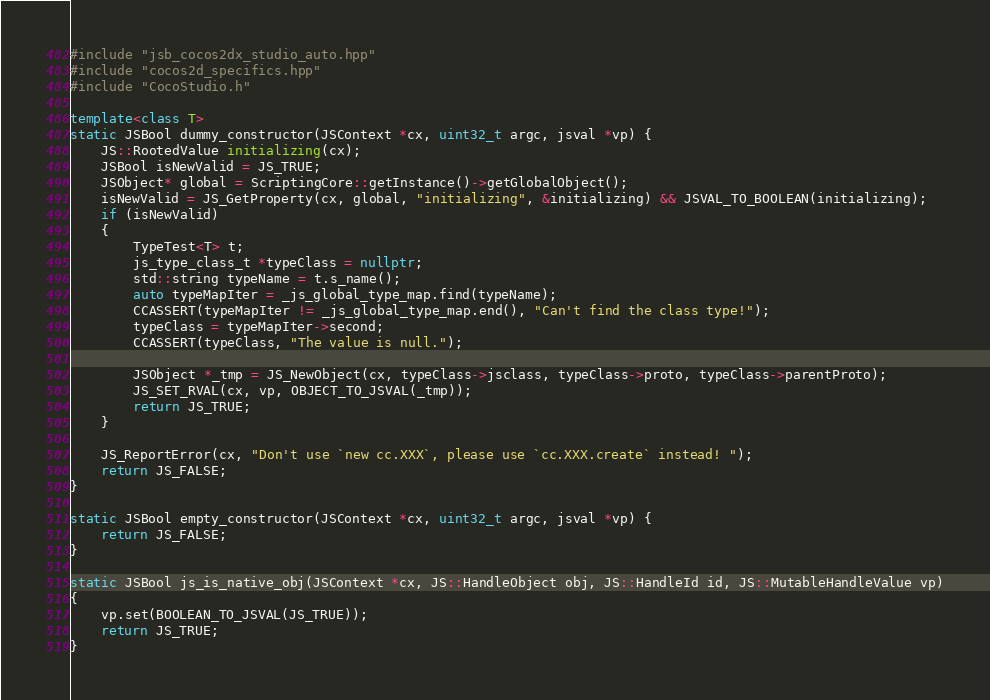<code> <loc_0><loc_0><loc_500><loc_500><_C++_>#include "jsb_cocos2dx_studio_auto.hpp"
#include "cocos2d_specifics.hpp"
#include "CocoStudio.h"

template<class T>
static JSBool dummy_constructor(JSContext *cx, uint32_t argc, jsval *vp) {
    JS::RootedValue initializing(cx);
    JSBool isNewValid = JS_TRUE;
    JSObject* global = ScriptingCore::getInstance()->getGlobalObject();
	isNewValid = JS_GetProperty(cx, global, "initializing", &initializing) && JSVAL_TO_BOOLEAN(initializing);
	if (isNewValid)
	{
		TypeTest<T> t;
		js_type_class_t *typeClass = nullptr;
		std::string typeName = t.s_name();
		auto typeMapIter = _js_global_type_map.find(typeName);
		CCASSERT(typeMapIter != _js_global_type_map.end(), "Can't find the class type!");
		typeClass = typeMapIter->second;
		CCASSERT(typeClass, "The value is null.");

		JSObject *_tmp = JS_NewObject(cx, typeClass->jsclass, typeClass->proto, typeClass->parentProto);
		JS_SET_RVAL(cx, vp, OBJECT_TO_JSVAL(_tmp));
		return JS_TRUE;
	}

    JS_ReportError(cx, "Don't use `new cc.XXX`, please use `cc.XXX.create` instead! ");
    return JS_FALSE;
}

static JSBool empty_constructor(JSContext *cx, uint32_t argc, jsval *vp) {
	return JS_FALSE;
}

static JSBool js_is_native_obj(JSContext *cx, JS::HandleObject obj, JS::HandleId id, JS::MutableHandleValue vp)
{
	vp.set(BOOLEAN_TO_JSVAL(JS_TRUE));
	return JS_TRUE;	
}</code> 